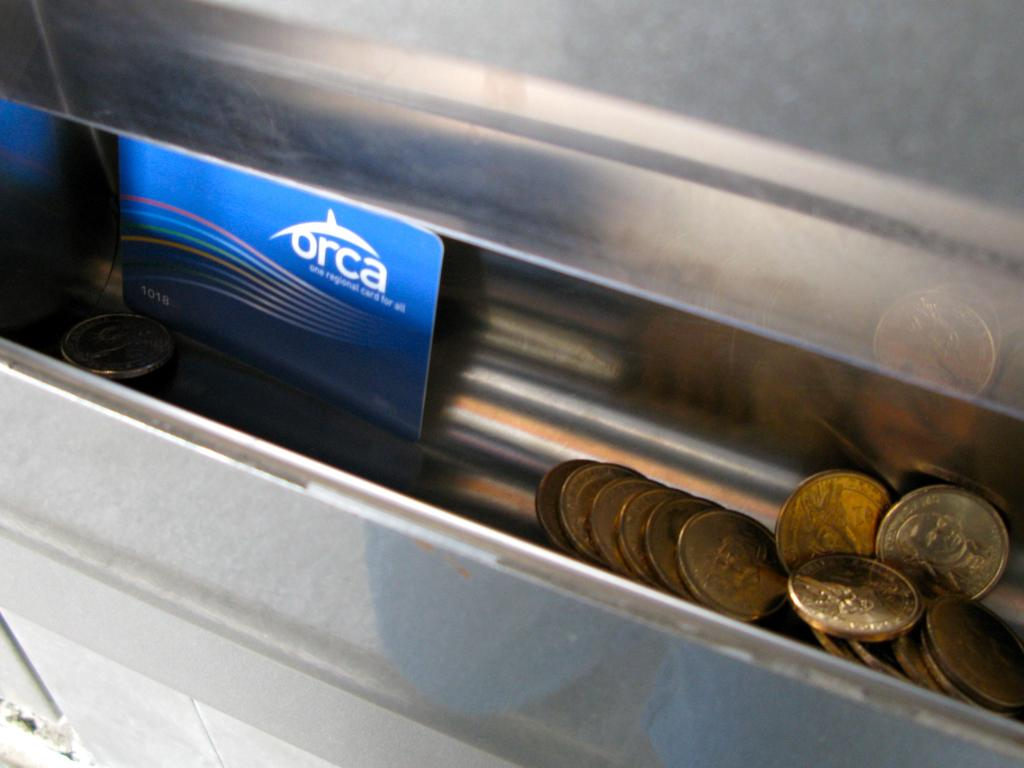<image>
Offer a succinct explanation of the picture presented. Many gold coins in a machine and also an Orca business card. 